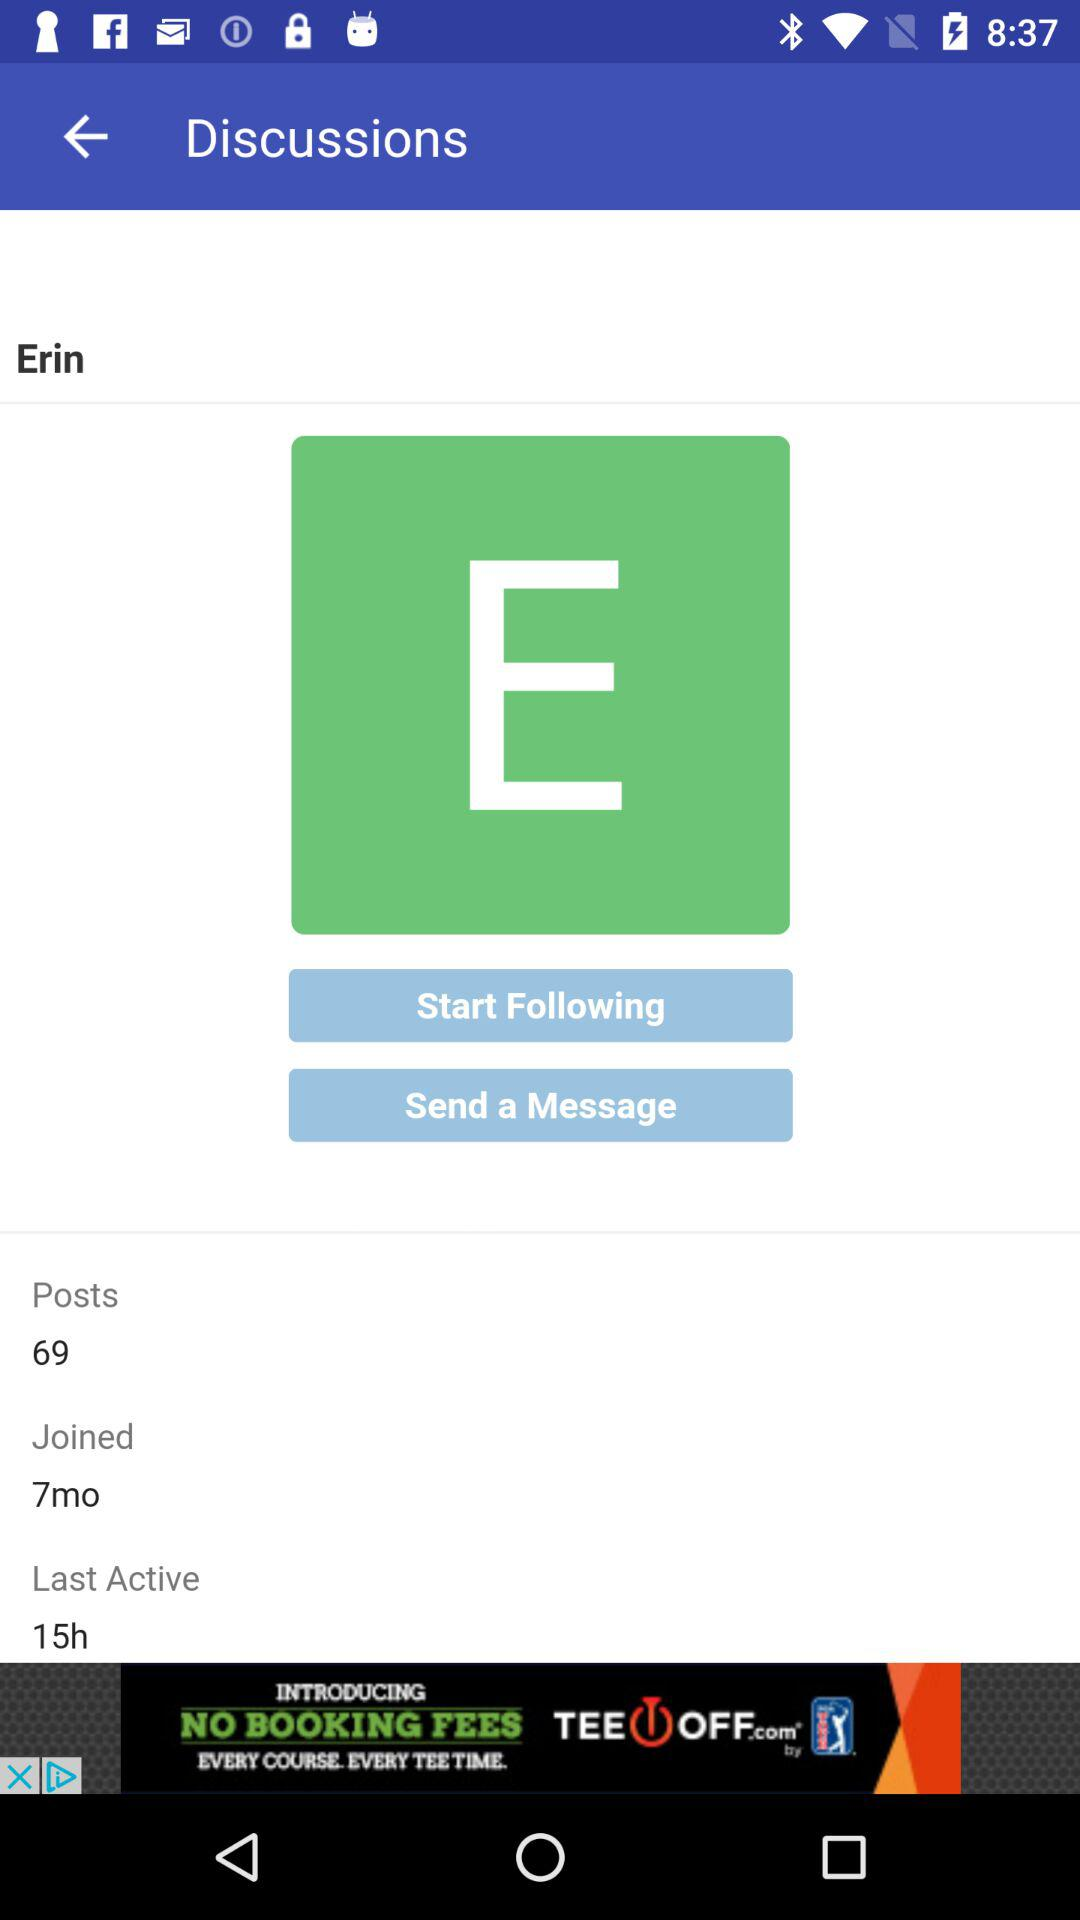How many months ago did the user join? The user joined 7 months ago. 